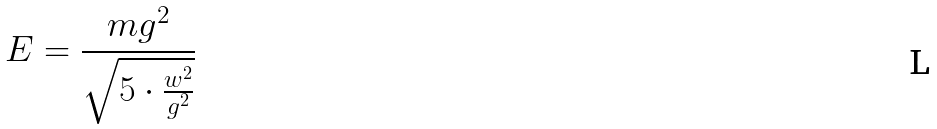Convert formula to latex. <formula><loc_0><loc_0><loc_500><loc_500>E = \frac { m g ^ { 2 } } { \sqrt { 5 \cdot \frac { w ^ { 2 } } { g ^ { 2 } } } }</formula> 